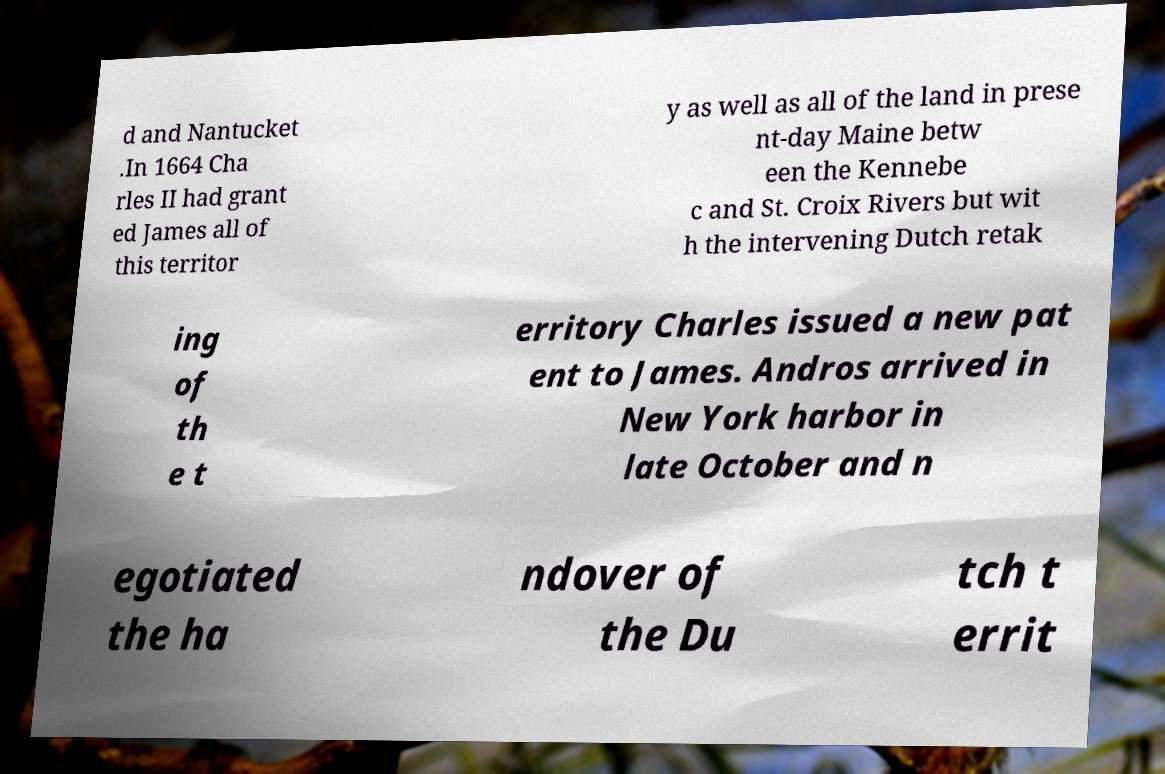Can you read and provide the text displayed in the image?This photo seems to have some interesting text. Can you extract and type it out for me? d and Nantucket .In 1664 Cha rles II had grant ed James all of this territor y as well as all of the land in prese nt-day Maine betw een the Kennebe c and St. Croix Rivers but wit h the intervening Dutch retak ing of th e t erritory Charles issued a new pat ent to James. Andros arrived in New York harbor in late October and n egotiated the ha ndover of the Du tch t errit 